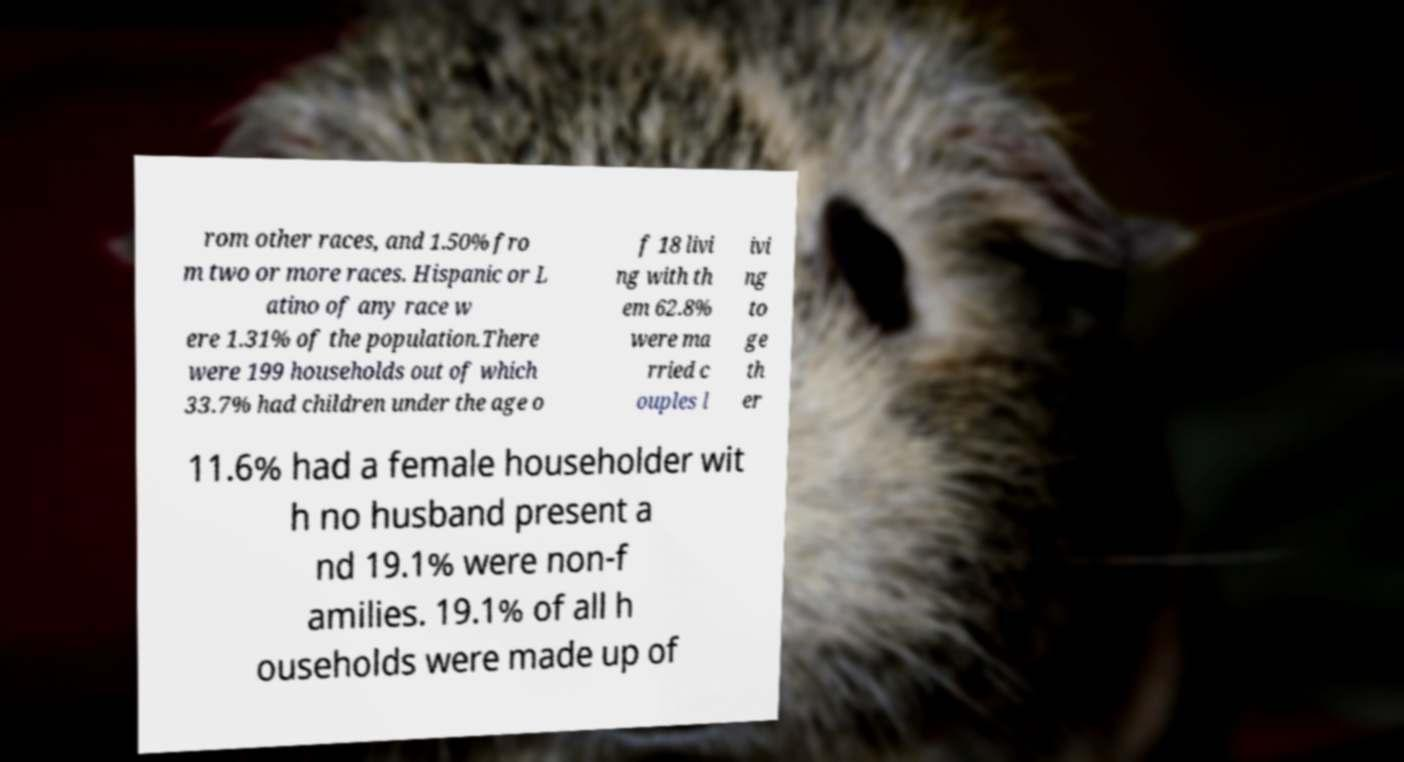Can you read and provide the text displayed in the image?This photo seems to have some interesting text. Can you extract and type it out for me? rom other races, and 1.50% fro m two or more races. Hispanic or L atino of any race w ere 1.31% of the population.There were 199 households out of which 33.7% had children under the age o f 18 livi ng with th em 62.8% were ma rried c ouples l ivi ng to ge th er 11.6% had a female householder wit h no husband present a nd 19.1% were non-f amilies. 19.1% of all h ouseholds were made up of 